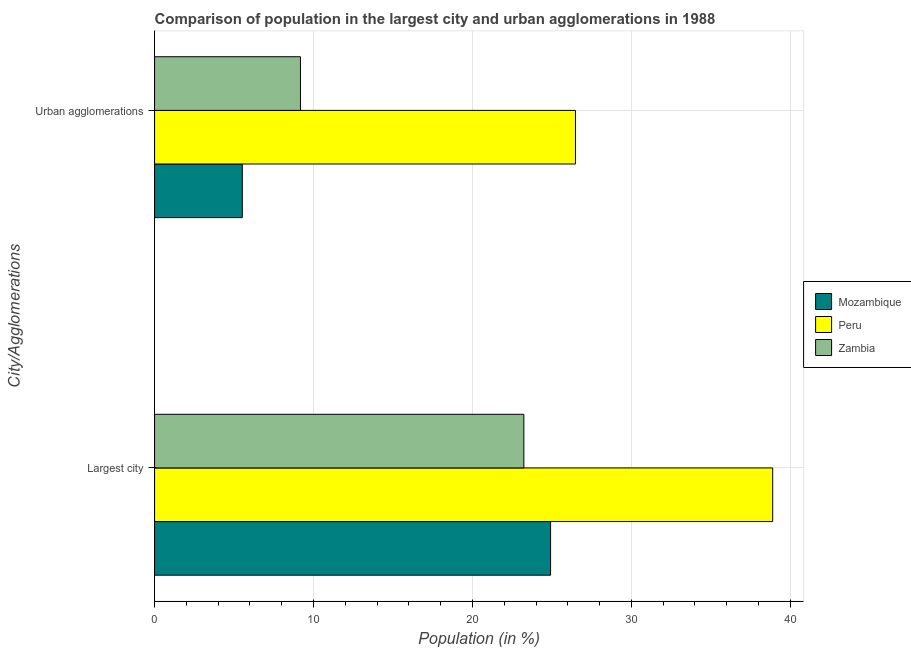How many different coloured bars are there?
Offer a terse response. 3. How many groups of bars are there?
Offer a terse response. 2. Are the number of bars per tick equal to the number of legend labels?
Your answer should be very brief. Yes. Are the number of bars on each tick of the Y-axis equal?
Keep it short and to the point. Yes. How many bars are there on the 2nd tick from the top?
Offer a very short reply. 3. How many bars are there on the 2nd tick from the bottom?
Provide a short and direct response. 3. What is the label of the 1st group of bars from the top?
Your answer should be very brief. Urban agglomerations. What is the population in the largest city in Zambia?
Offer a very short reply. 23.23. Across all countries, what is the maximum population in the largest city?
Give a very brief answer. 38.89. Across all countries, what is the minimum population in the largest city?
Ensure brevity in your answer.  23.23. In which country was the population in urban agglomerations maximum?
Keep it short and to the point. Peru. In which country was the population in urban agglomerations minimum?
Give a very brief answer. Mozambique. What is the total population in urban agglomerations in the graph?
Provide a short and direct response. 41.18. What is the difference between the population in the largest city in Zambia and that in Mozambique?
Your answer should be compact. -1.68. What is the difference between the population in urban agglomerations in Zambia and the population in the largest city in Peru?
Offer a very short reply. -29.71. What is the average population in urban agglomerations per country?
Your answer should be compact. 13.73. What is the difference between the population in the largest city and population in urban agglomerations in Zambia?
Ensure brevity in your answer.  14.05. In how many countries, is the population in the largest city greater than 14 %?
Your response must be concise. 3. What is the ratio of the population in urban agglomerations in Mozambique to that in Zambia?
Provide a short and direct response. 0.6. Is the population in the largest city in Mozambique less than that in Zambia?
Ensure brevity in your answer.  No. In how many countries, is the population in the largest city greater than the average population in the largest city taken over all countries?
Provide a succinct answer. 1. What does the 3rd bar from the bottom in Urban agglomerations represents?
Your answer should be compact. Zambia. How many bars are there?
Your answer should be very brief. 6. How many countries are there in the graph?
Provide a succinct answer. 3. What is the difference between two consecutive major ticks on the X-axis?
Your answer should be compact. 10. Are the values on the major ticks of X-axis written in scientific E-notation?
Your response must be concise. No. Does the graph contain any zero values?
Provide a succinct answer. No. Where does the legend appear in the graph?
Keep it short and to the point. Center right. How are the legend labels stacked?
Give a very brief answer. Vertical. What is the title of the graph?
Offer a very short reply. Comparison of population in the largest city and urban agglomerations in 1988. What is the label or title of the X-axis?
Keep it short and to the point. Population (in %). What is the label or title of the Y-axis?
Keep it short and to the point. City/Agglomerations. What is the Population (in %) in Mozambique in Largest city?
Make the answer very short. 24.91. What is the Population (in %) of Peru in Largest city?
Provide a short and direct response. 38.89. What is the Population (in %) in Zambia in Largest city?
Provide a succinct answer. 23.23. What is the Population (in %) in Mozambique in Urban agglomerations?
Offer a terse response. 5.52. What is the Population (in %) in Peru in Urban agglomerations?
Your response must be concise. 26.48. What is the Population (in %) in Zambia in Urban agglomerations?
Provide a short and direct response. 9.18. Across all City/Agglomerations, what is the maximum Population (in %) of Mozambique?
Keep it short and to the point. 24.91. Across all City/Agglomerations, what is the maximum Population (in %) of Peru?
Your answer should be compact. 38.89. Across all City/Agglomerations, what is the maximum Population (in %) in Zambia?
Make the answer very short. 23.23. Across all City/Agglomerations, what is the minimum Population (in %) of Mozambique?
Ensure brevity in your answer.  5.52. Across all City/Agglomerations, what is the minimum Population (in %) in Peru?
Offer a very short reply. 26.48. Across all City/Agglomerations, what is the minimum Population (in %) of Zambia?
Your response must be concise. 9.18. What is the total Population (in %) in Mozambique in the graph?
Ensure brevity in your answer.  30.43. What is the total Population (in %) of Peru in the graph?
Your answer should be very brief. 65.37. What is the total Population (in %) of Zambia in the graph?
Make the answer very short. 32.41. What is the difference between the Population (in %) of Mozambique in Largest city and that in Urban agglomerations?
Give a very brief answer. 19.4. What is the difference between the Population (in %) in Peru in Largest city and that in Urban agglomerations?
Your response must be concise. 12.41. What is the difference between the Population (in %) in Zambia in Largest city and that in Urban agglomerations?
Offer a very short reply. 14.05. What is the difference between the Population (in %) of Mozambique in Largest city and the Population (in %) of Peru in Urban agglomerations?
Give a very brief answer. -1.57. What is the difference between the Population (in %) of Mozambique in Largest city and the Population (in %) of Zambia in Urban agglomerations?
Offer a very short reply. 15.74. What is the difference between the Population (in %) in Peru in Largest city and the Population (in %) in Zambia in Urban agglomerations?
Offer a terse response. 29.71. What is the average Population (in %) of Mozambique per City/Agglomerations?
Provide a short and direct response. 15.22. What is the average Population (in %) in Peru per City/Agglomerations?
Your answer should be very brief. 32.68. What is the average Population (in %) in Zambia per City/Agglomerations?
Your answer should be very brief. 16.21. What is the difference between the Population (in %) in Mozambique and Population (in %) in Peru in Largest city?
Provide a succinct answer. -13.97. What is the difference between the Population (in %) of Mozambique and Population (in %) of Zambia in Largest city?
Provide a succinct answer. 1.68. What is the difference between the Population (in %) of Peru and Population (in %) of Zambia in Largest city?
Offer a very short reply. 15.65. What is the difference between the Population (in %) in Mozambique and Population (in %) in Peru in Urban agglomerations?
Your response must be concise. -20.96. What is the difference between the Population (in %) in Mozambique and Population (in %) in Zambia in Urban agglomerations?
Provide a succinct answer. -3.66. What is the difference between the Population (in %) of Peru and Population (in %) of Zambia in Urban agglomerations?
Provide a short and direct response. 17.3. What is the ratio of the Population (in %) of Mozambique in Largest city to that in Urban agglomerations?
Keep it short and to the point. 4.51. What is the ratio of the Population (in %) in Peru in Largest city to that in Urban agglomerations?
Your response must be concise. 1.47. What is the ratio of the Population (in %) of Zambia in Largest city to that in Urban agglomerations?
Your answer should be compact. 2.53. What is the difference between the highest and the second highest Population (in %) in Mozambique?
Your answer should be compact. 19.4. What is the difference between the highest and the second highest Population (in %) in Peru?
Your response must be concise. 12.41. What is the difference between the highest and the second highest Population (in %) in Zambia?
Your answer should be very brief. 14.05. What is the difference between the highest and the lowest Population (in %) in Mozambique?
Ensure brevity in your answer.  19.4. What is the difference between the highest and the lowest Population (in %) in Peru?
Your answer should be compact. 12.41. What is the difference between the highest and the lowest Population (in %) of Zambia?
Make the answer very short. 14.05. 